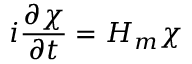<formula> <loc_0><loc_0><loc_500><loc_500>i \frac { \partial \chi } { \partial t } = H _ { m } \chi</formula> 